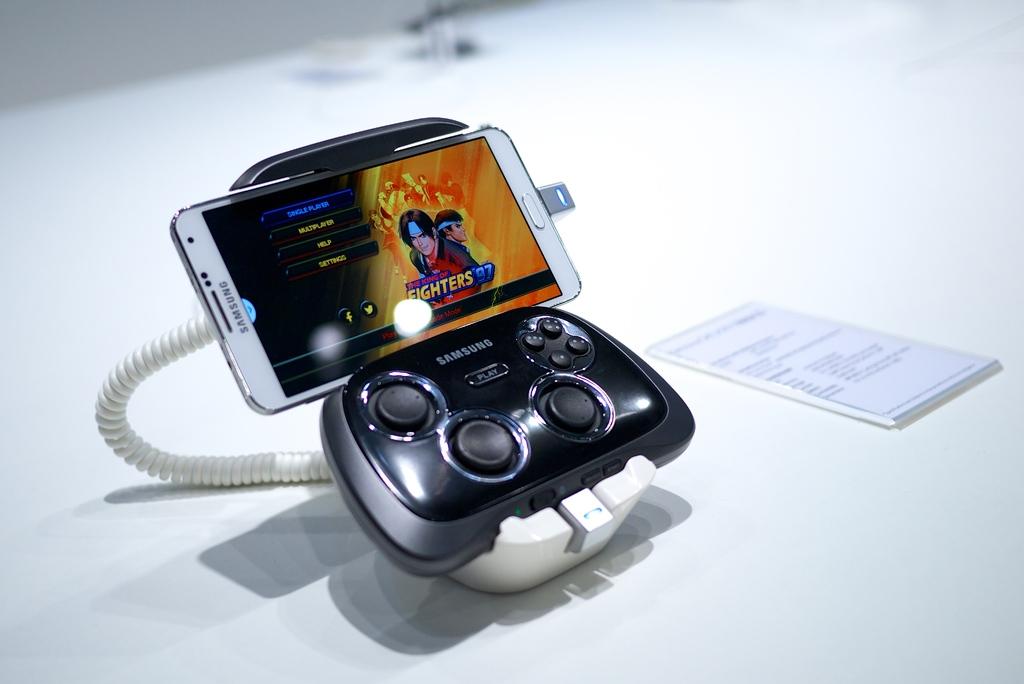What brand is this phone?
Your answer should be very brief. Samsung. What is the game on the phone called?
Offer a terse response. Fighters 97. 